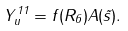Convert formula to latex. <formula><loc_0><loc_0><loc_500><loc_500>Y _ { u } ^ { 1 1 } = f ( R _ { 6 } ) A ( \tilde { s } ) .</formula> 